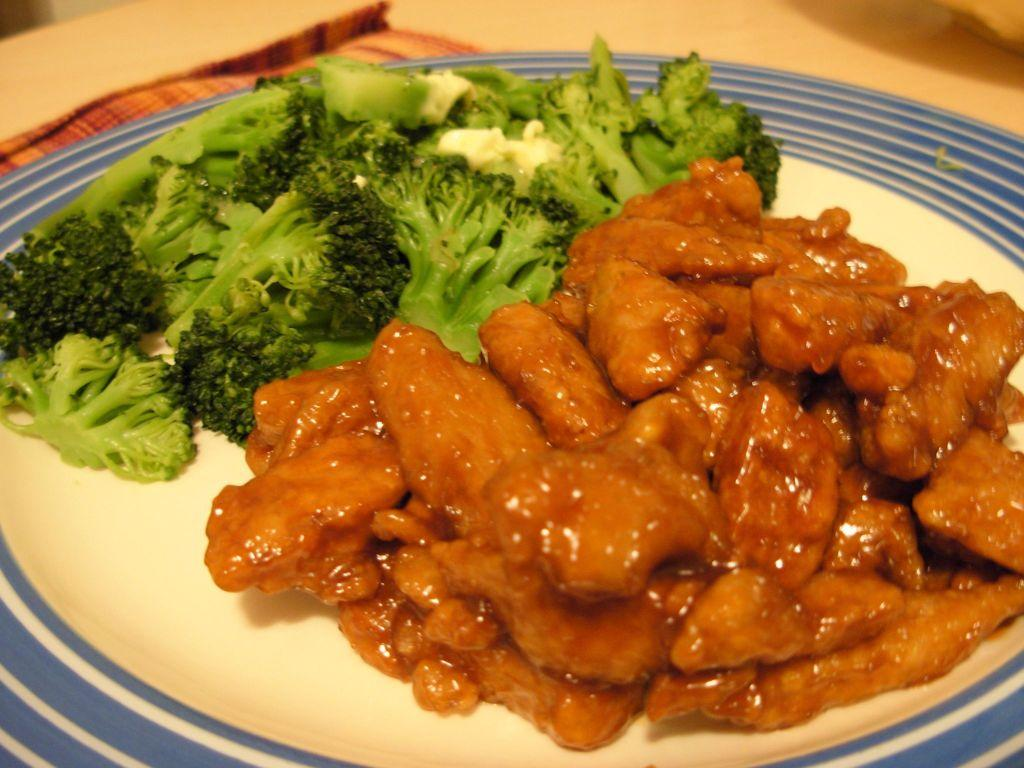What vegetable is on the plate in the image? There is Broccoli on a plate in the image. What other food item is on the plate? There is another food item on the plate, but its specific type is not mentioned in the facts. Where is the plate located? The plate is on top of a table. What hobbies does the Broccoli enjoy in the image? The facts provided do not mention any hobbies for the Broccoli, as it is an inanimate object and does not have hobbies. 